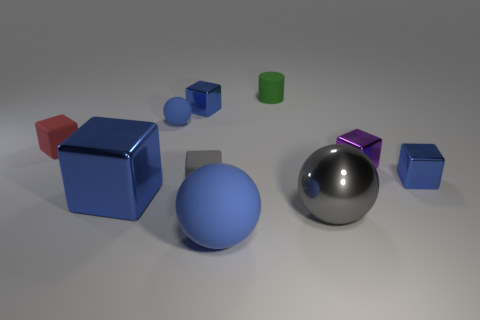Do the big matte ball and the large metallic block have the same color? Yes, both the large matte ball and the large metallic block share the same hue of blue. However, it's interesting to note that despite having the same color, the texture differences between matte and metallic surfaces create unique reflections of light, giving them a distinctive appearance. 